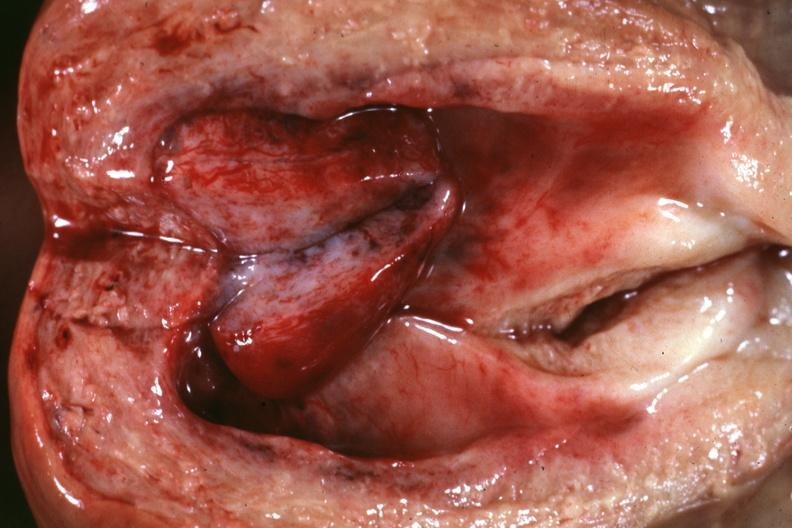s lesion present?
Answer the question using a single word or phrase. No 